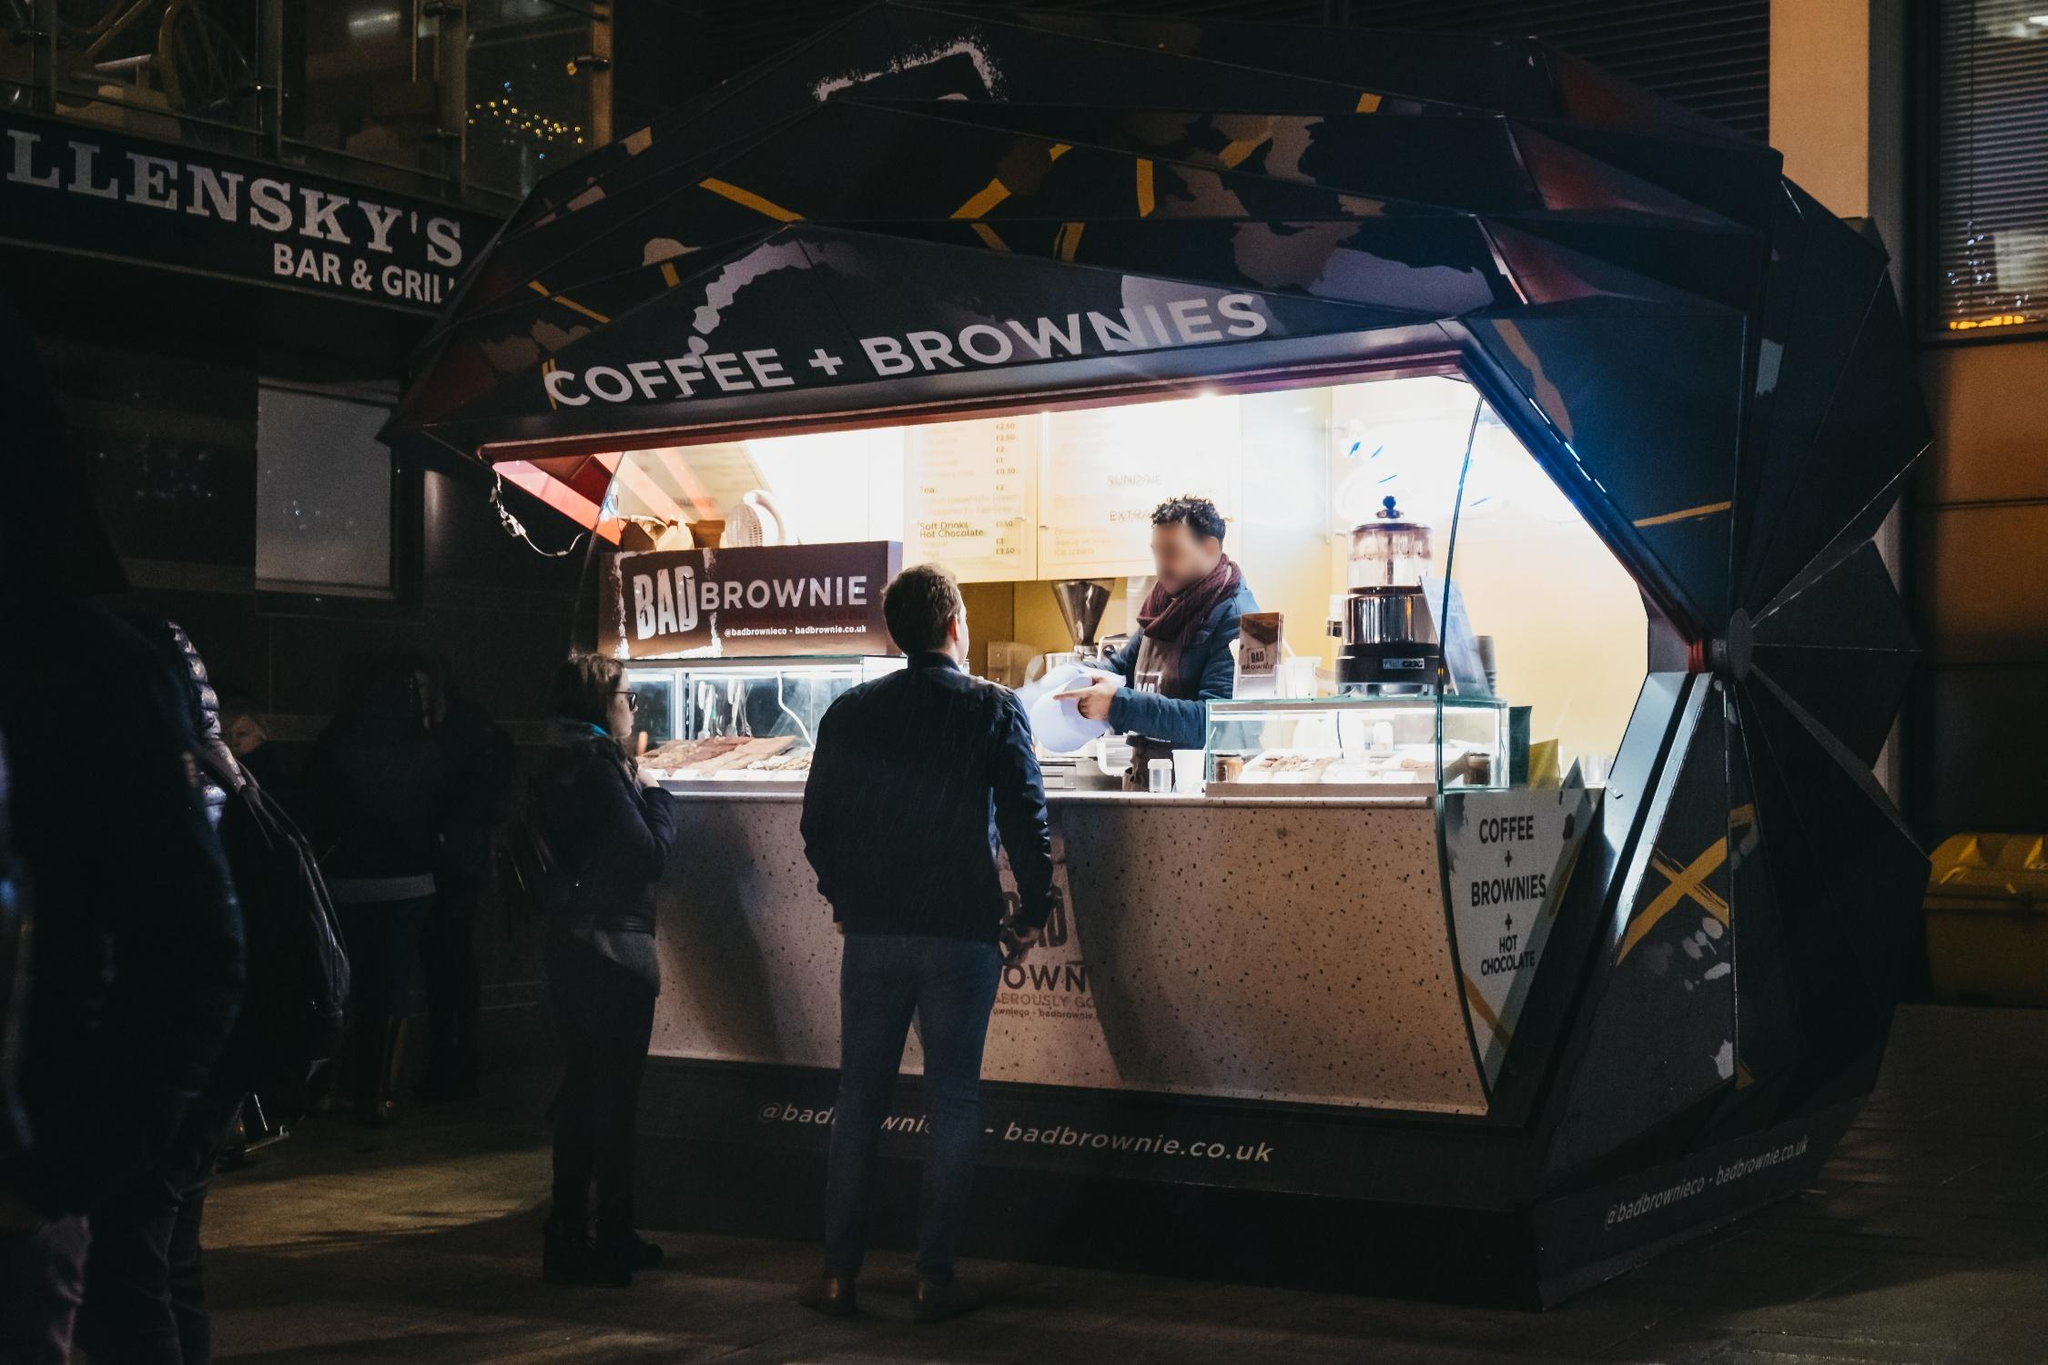What does the atmosphere around the stall tell us about the location and time? The image suggests a brisk, vibrant urban setting at night, likely in a downtown area bustling with nightlife activity. The crowd’s bundled attire hints at cooler weather, perhaps in late autumn or early winter. The nearby signs of other bars and eateries along with the style of street lighting and architecture suggest a contemporary cityscape that comes alive after dark. Is there anything unique about this stall’s design? Yes, the stall’s hexagonal structure is quite distinctive, providing an angular contrast to the usual rectilinear shapes seen in food trucks and stands. Its broad, transparent front allows onlookers to clearly view the brownie selection and preparation process, creating an open, welcoming feel. The distinctive awning adds a nostalgic touch, reminiscent of old-fashioned market stalls. 